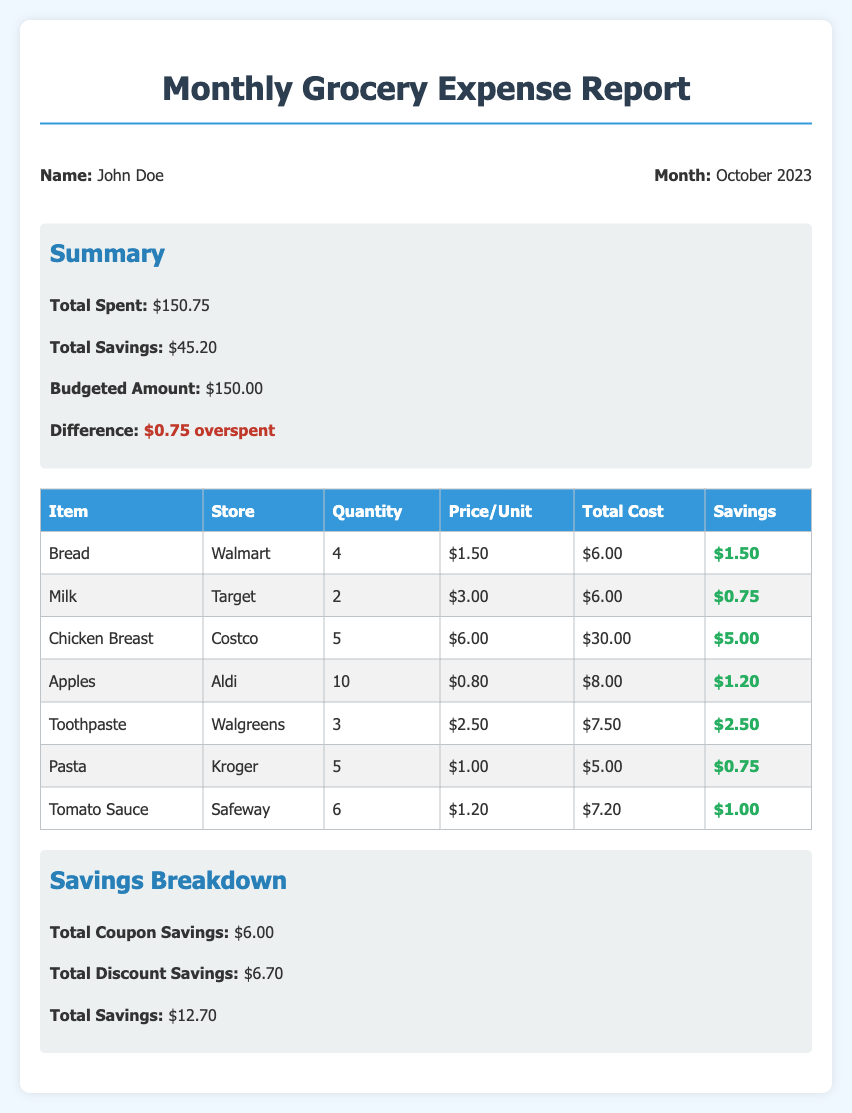What was the total amount spent? The total amount spent is explicitly stated in the summary section of the document.
Answer: $150.75 How much savings was achieved from coupons? The total coupon savings are listed under the Savings Breakdown section of the document.
Answer: $6.00 What is the budgeted amount? The budgeted amount is presented in the summary section, which outlines budgetary limits.
Answer: $150.00 How many items of Toothpaste were purchased? The quantity for Toothpaste is specified in the itemized table.
Answer: 3 Which store sold Chicken Breast? The store for Chicken Breast is indicated in the table alongside its corresponding item.
Answer: Costco Was any amount overspent? The summary section shows whether the spending exceeded the budget.
Answer: $0.75 overspent What is the total savings reported in the document? Total savings is highlighted in the summary section, representing cumulative savings.
Answer: $45.20 How many Apples were bought? The quantity of Apples is detailed in the itemized list of purchases.
Answer: 10 What was the price per unit of Pasta? The price per unit for Pasta is listed in the grocery itemization table.
Answer: $1.00 